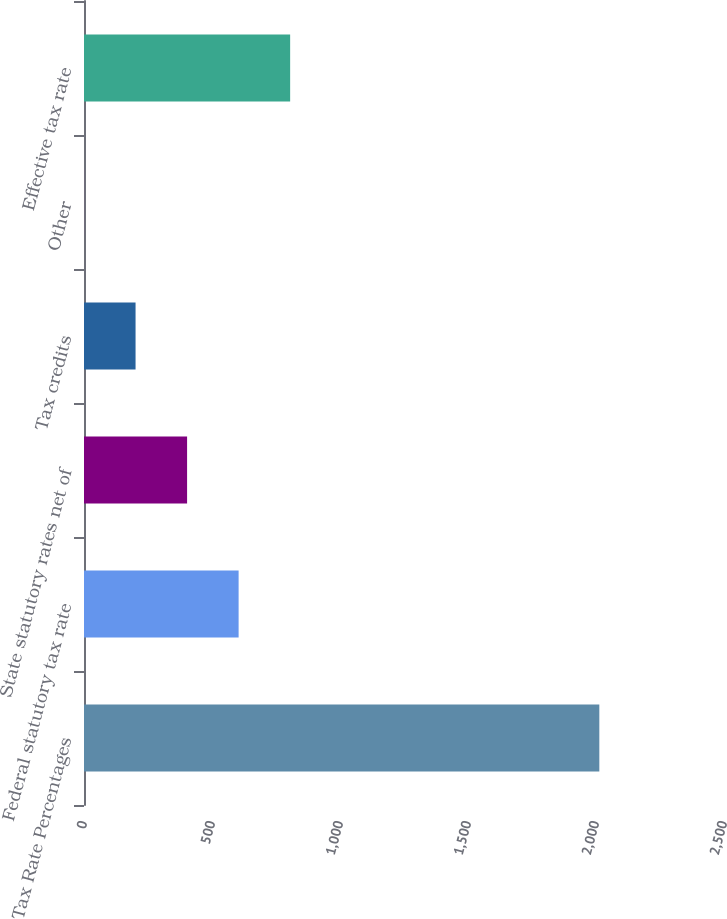<chart> <loc_0><loc_0><loc_500><loc_500><bar_chart><fcel>Tax Rate Percentages<fcel>Federal statutory tax rate<fcel>State statutory rates net of<fcel>Tax credits<fcel>Other<fcel>Effective tax rate<nl><fcel>2013<fcel>603.97<fcel>402.68<fcel>201.39<fcel>0.1<fcel>805.26<nl></chart> 